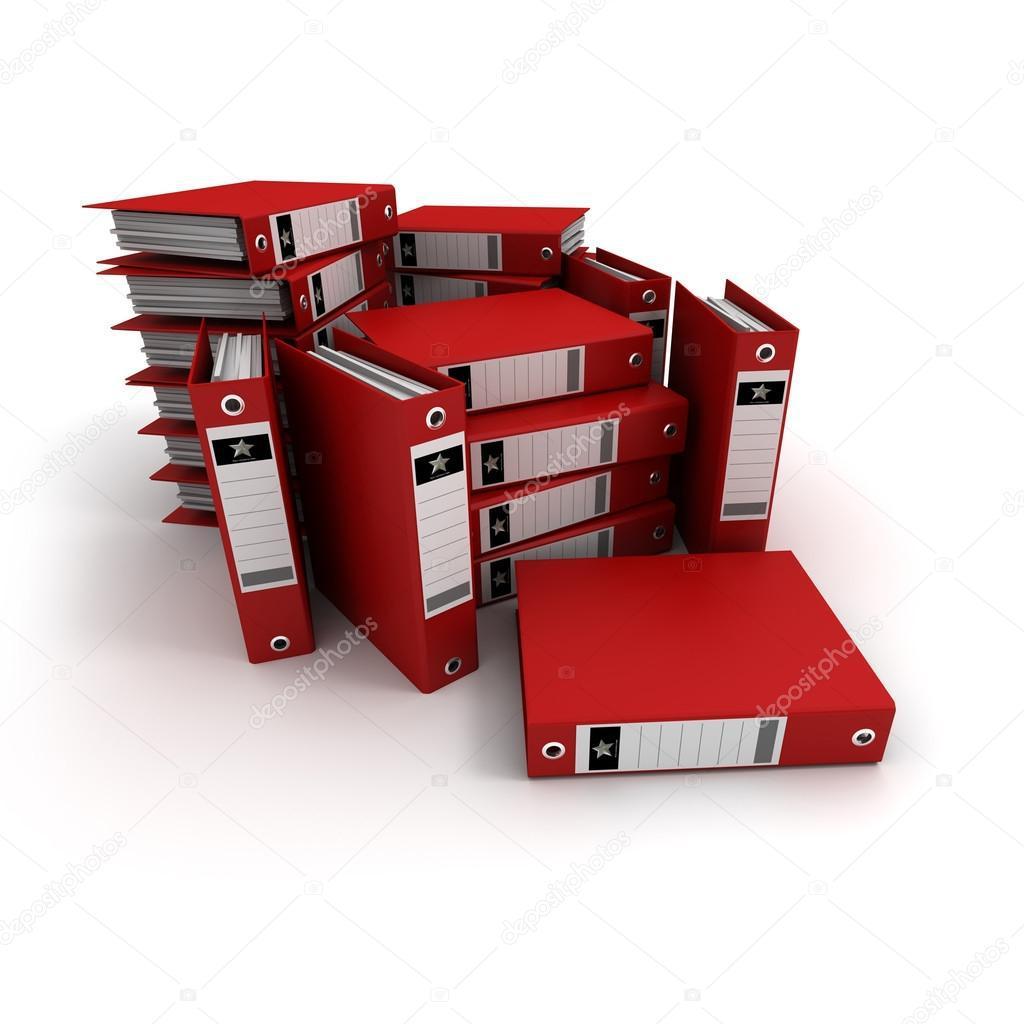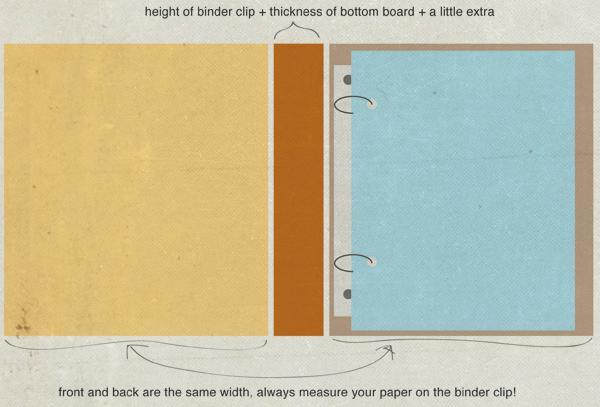The first image is the image on the left, the second image is the image on the right. Assess this claim about the two images: "There is a collection of red binders.". Correct or not? Answer yes or no. Yes. The first image is the image on the left, the second image is the image on the right. For the images displayed, is the sentence "In one image all the binders are red." factually correct? Answer yes or no. Yes. 